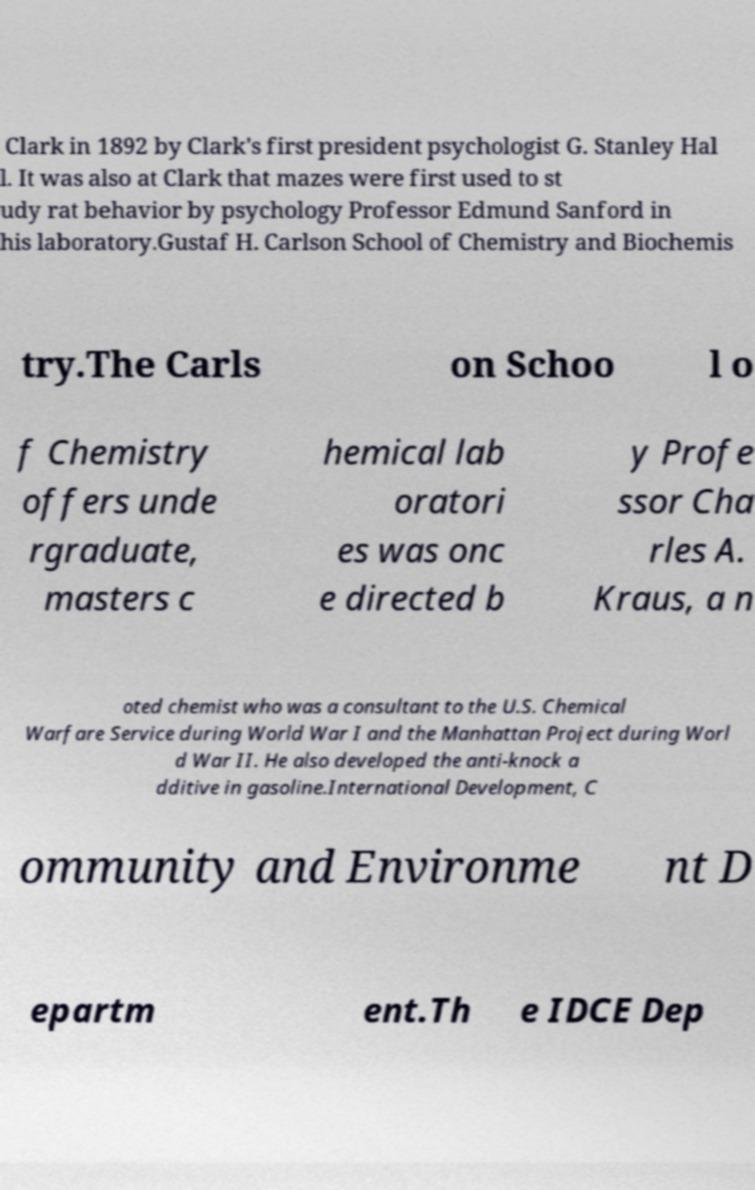Please identify and transcribe the text found in this image. Clark in 1892 by Clark's first president psychologist G. Stanley Hal l. It was also at Clark that mazes were first used to st udy rat behavior by psychology Professor Edmund Sanford in his laboratory.Gustaf H. Carlson School of Chemistry and Biochemis try.The Carls on Schoo l o f Chemistry offers unde rgraduate, masters c hemical lab oratori es was onc e directed b y Profe ssor Cha rles A. Kraus, a n oted chemist who was a consultant to the U.S. Chemical Warfare Service during World War I and the Manhattan Project during Worl d War II. He also developed the anti-knock a dditive in gasoline.International Development, C ommunity and Environme nt D epartm ent.Th e IDCE Dep 